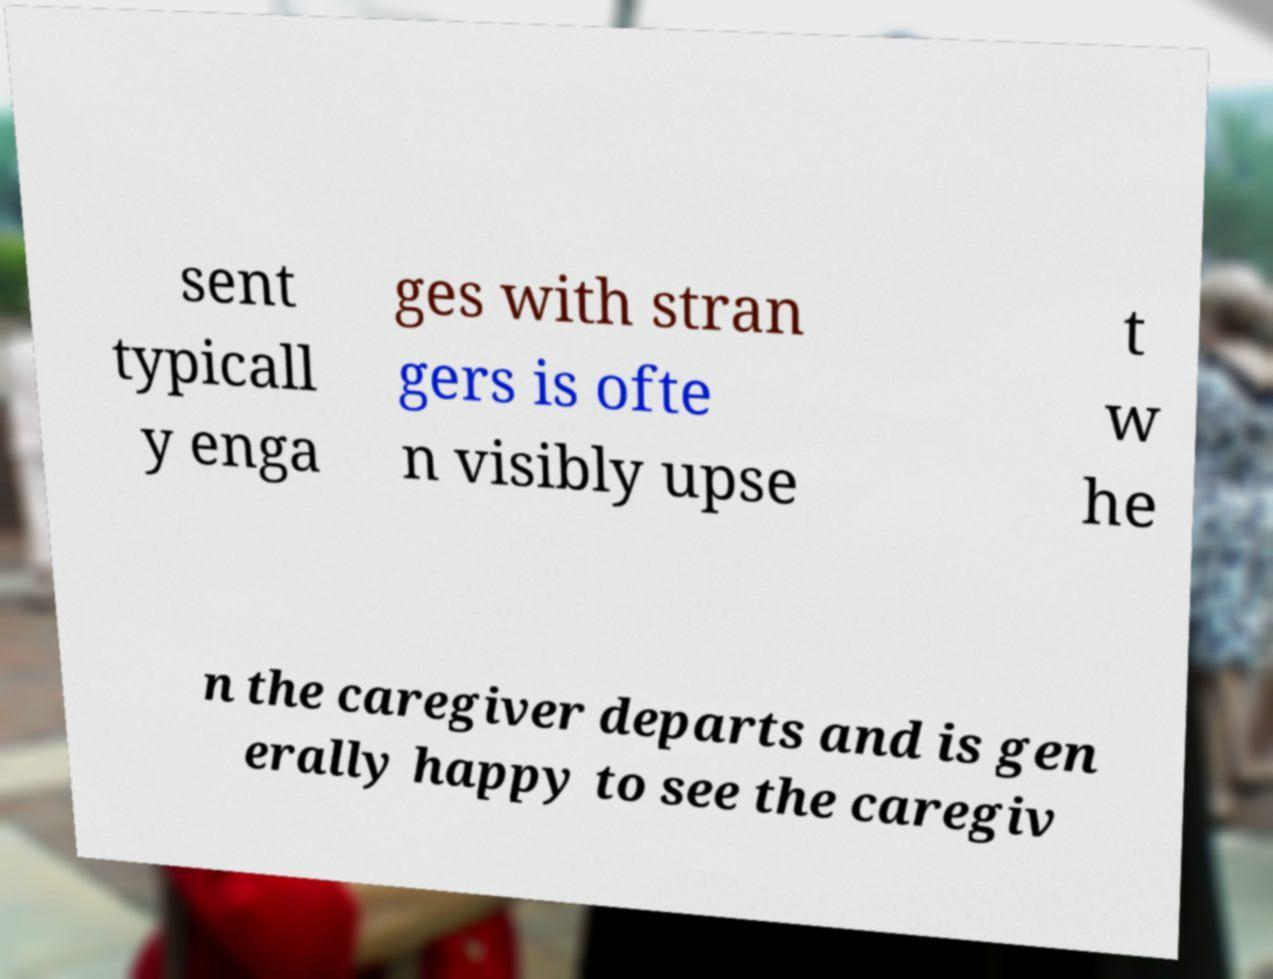There's text embedded in this image that I need extracted. Can you transcribe it verbatim? sent typicall y enga ges with stran gers is ofte n visibly upse t w he n the caregiver departs and is gen erally happy to see the caregiv 